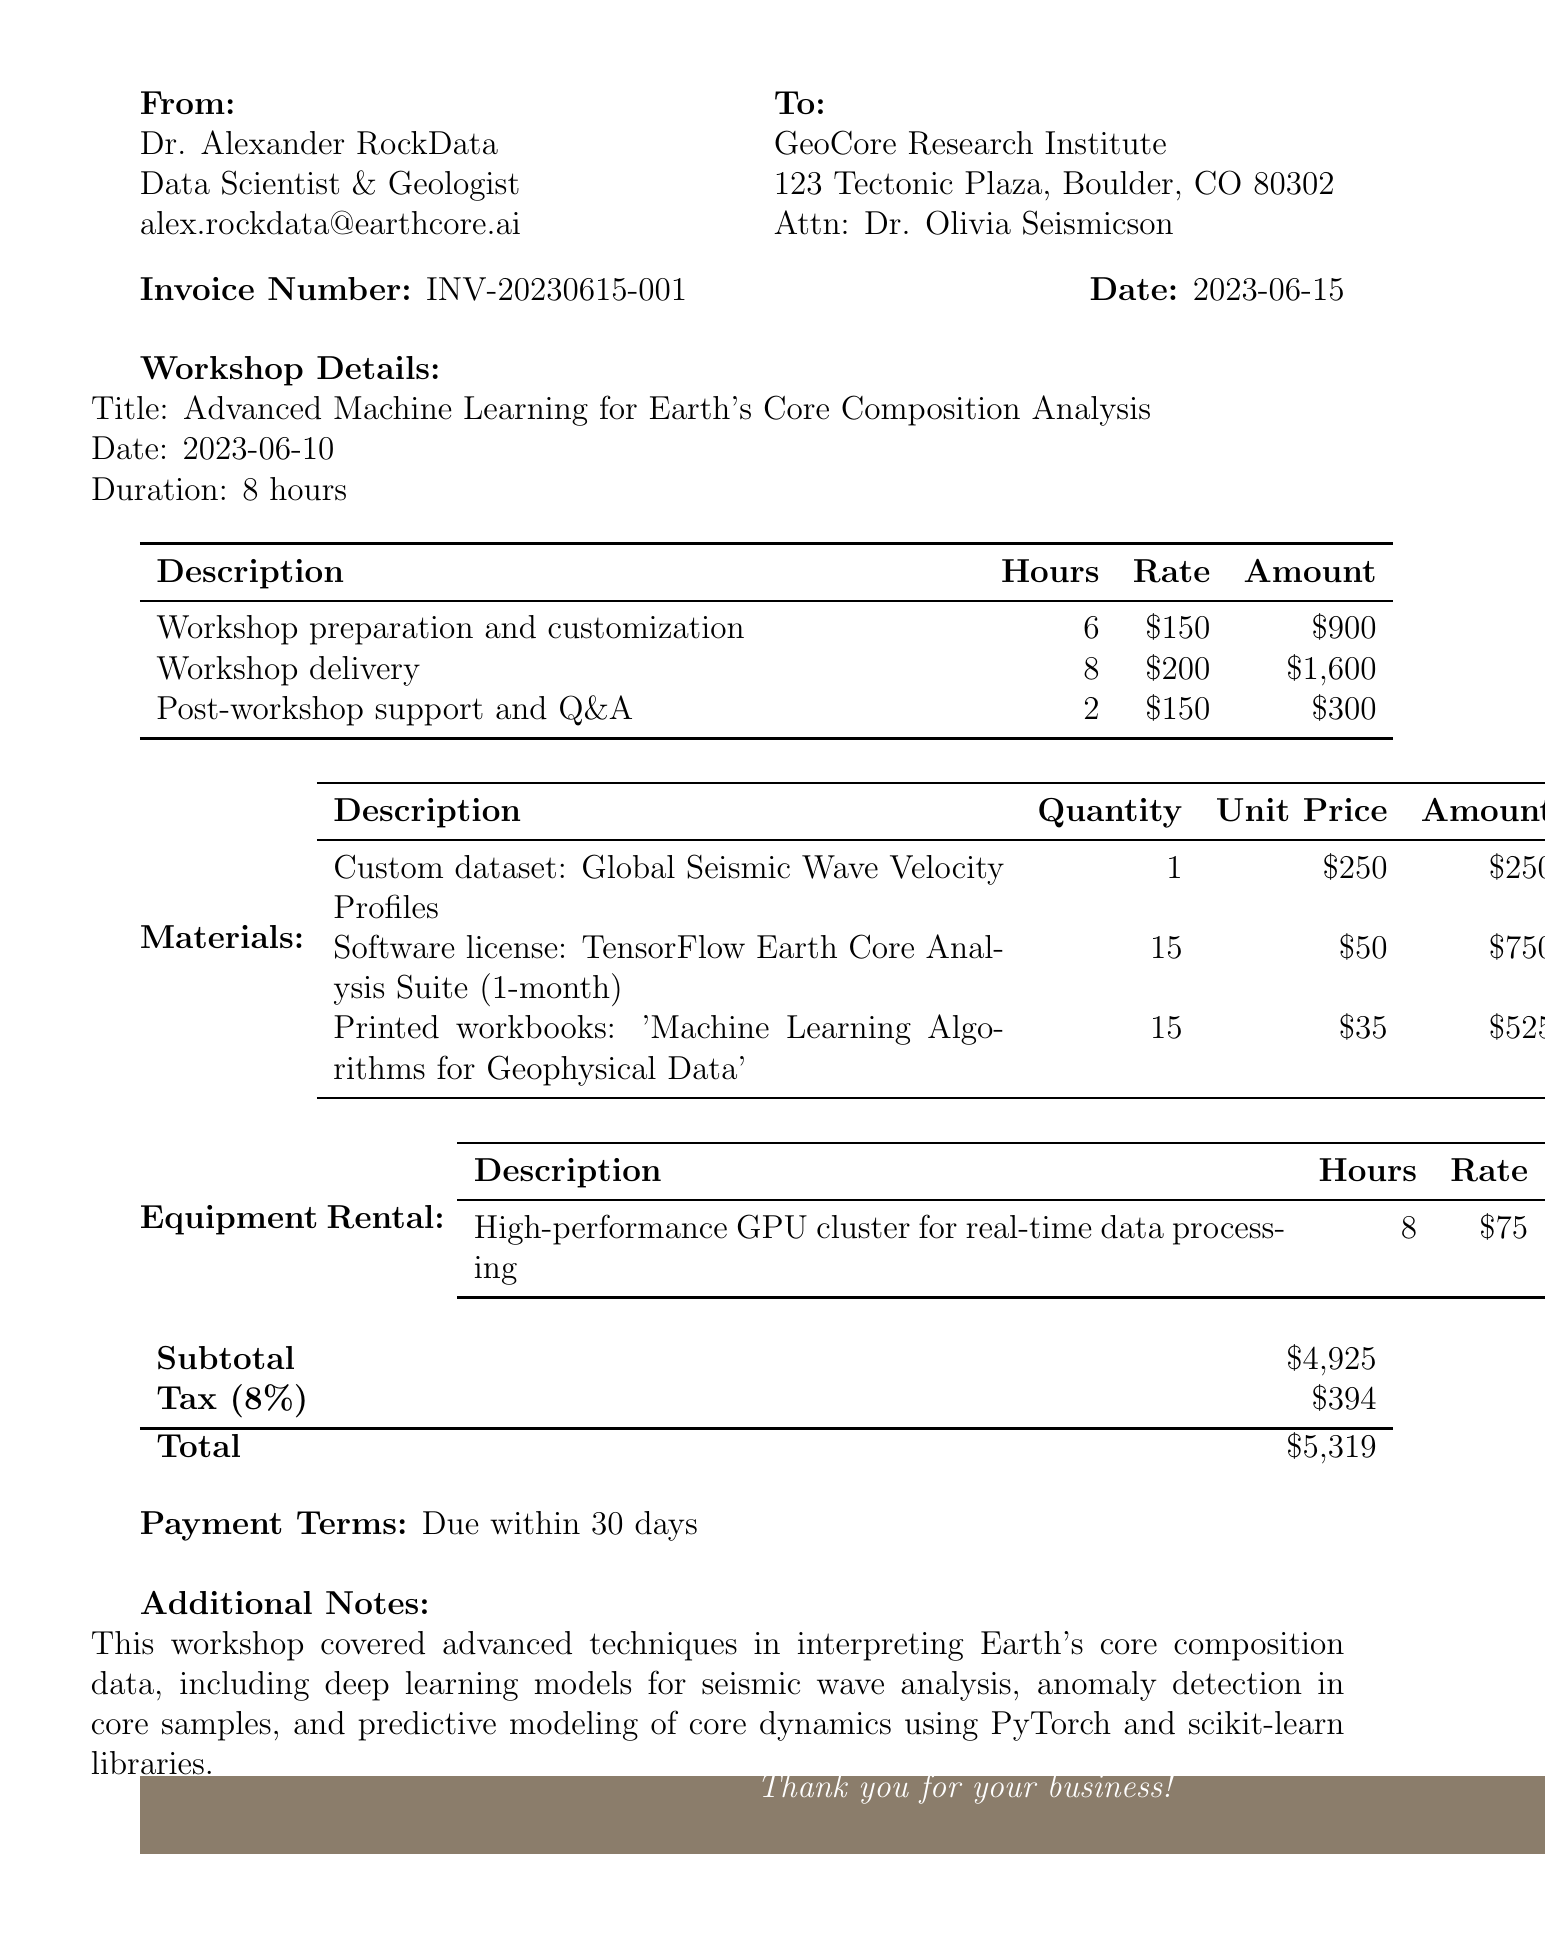What is the invoice number? The invoice number is specified in the document under the invoice details section.
Answer: INV-20230615-001 Who is the consultant? The consultant's name and title are listed at the top of the document.
Answer: Dr. Alexander RockData What is the date of the workshop? The workshop date is mentioned in the workshop details section.
Answer: 2023-06-10 What is the total amount due? The total amount due is provided at the bottom of the document.
Answer: 5319 How many hours were dedicated to workshop delivery? The hours for workshop delivery are detailed in the line items of the invoice.
Answer: 8 What is the tax rate applied? The tax rate is indicated near the total calculations section.
Answer: 8% What is included in the materials section? The materials section lists specific items and their prices associated with the workshop.
Answer: Custom dataset, Software license, Printed workbooks What is the payment term? The payment terms are stated at the end of the invoice.
Answer: Due within 30 days How long was the workshop? The duration of the workshop is mentioned in the workshop details section.
Answer: 8 hours What type of equipment was rented? The equipment rental section specifies the type of equipment used.
Answer: High-performance GPU cluster 